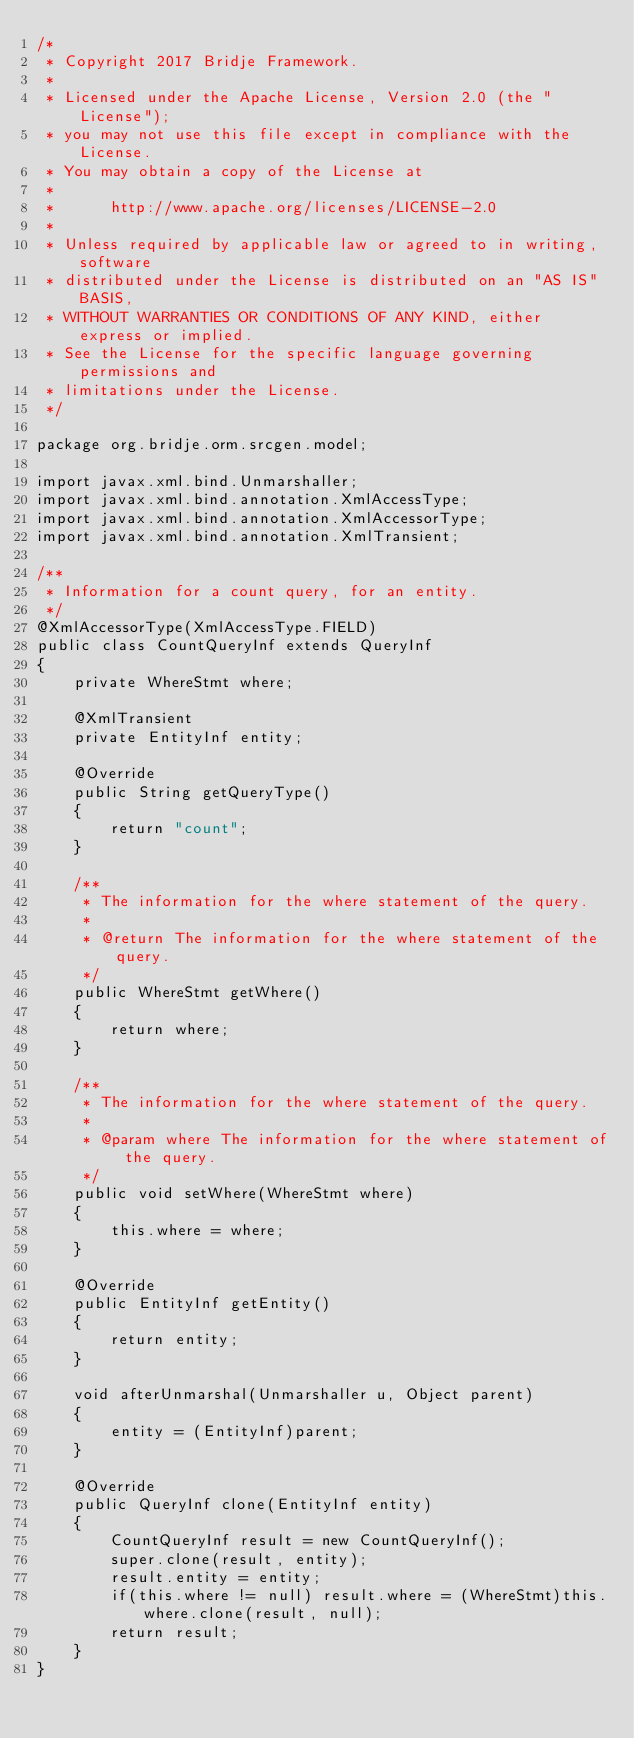Convert code to text. <code><loc_0><loc_0><loc_500><loc_500><_Java_>/*
 * Copyright 2017 Bridje Framework.
 *
 * Licensed under the Apache License, Version 2.0 (the "License");
 * you may not use this file except in compliance with the License.
 * You may obtain a copy of the License at
 *
 *      http://www.apache.org/licenses/LICENSE-2.0
 *
 * Unless required by applicable law or agreed to in writing, software
 * distributed under the License is distributed on an "AS IS" BASIS,
 * WITHOUT WARRANTIES OR CONDITIONS OF ANY KIND, either express or implied.
 * See the License for the specific language governing permissions and
 * limitations under the License.
 */

package org.bridje.orm.srcgen.model;

import javax.xml.bind.Unmarshaller;
import javax.xml.bind.annotation.XmlAccessType;
import javax.xml.bind.annotation.XmlAccessorType;
import javax.xml.bind.annotation.XmlTransient;

/**
 * Information for a count query, for an entity.
 */
@XmlAccessorType(XmlAccessType.FIELD)
public class CountQueryInf extends QueryInf
{
    private WhereStmt where;

    @XmlTransient
    private EntityInf entity;

    @Override
    public String getQueryType()
    {
        return "count";
    }

    /**
     * The information for the where statement of the query.
     * 
     * @return The information for the where statement of the query.
     */
    public WhereStmt getWhere()
    {
        return where;
    }

    /**
     * The information for the where statement of the query.
     * 
     * @param where The information for the where statement of the query.
     */
    public void setWhere(WhereStmt where)
    {
        this.where = where;
    }

    @Override
    public EntityInf getEntity()
    {
        return entity;
    }

    void afterUnmarshal(Unmarshaller u, Object parent)
    {
        entity = (EntityInf)parent;
    }

    @Override
    public QueryInf clone(EntityInf entity)
    {
        CountQueryInf result = new CountQueryInf();
        super.clone(result, entity);
        result.entity = entity;
        if(this.where != null) result.where = (WhereStmt)this.where.clone(result, null);
        return result;
    }
}
</code> 